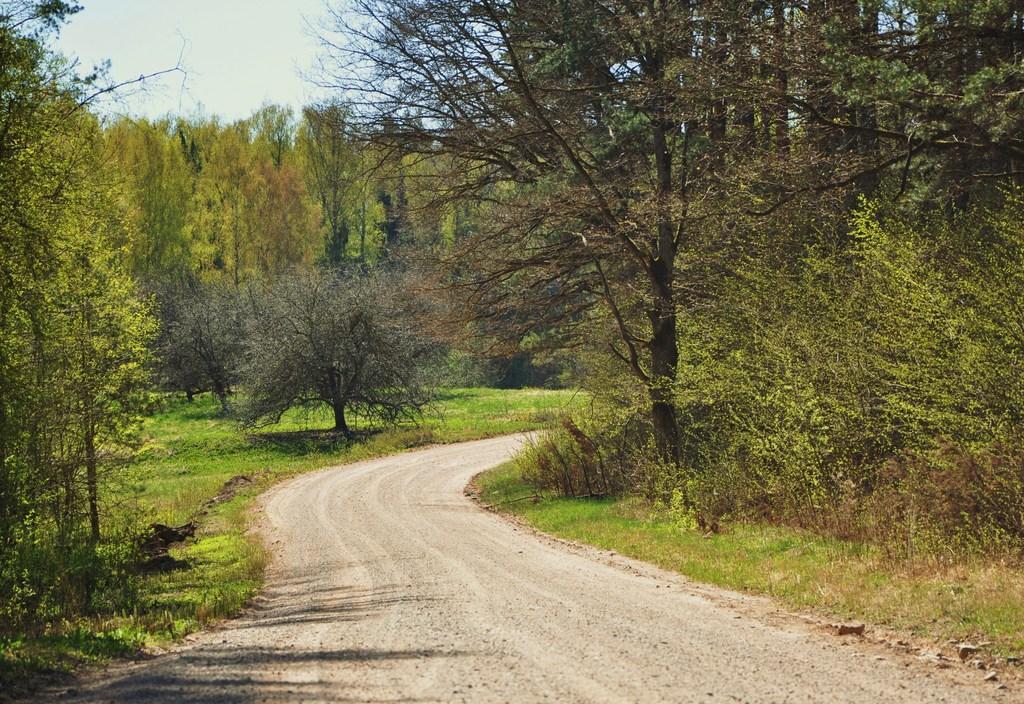In one or two sentences, can you explain what this image depicts? This picture consists of grass, trees and the sky. This image might be taken during a day. 